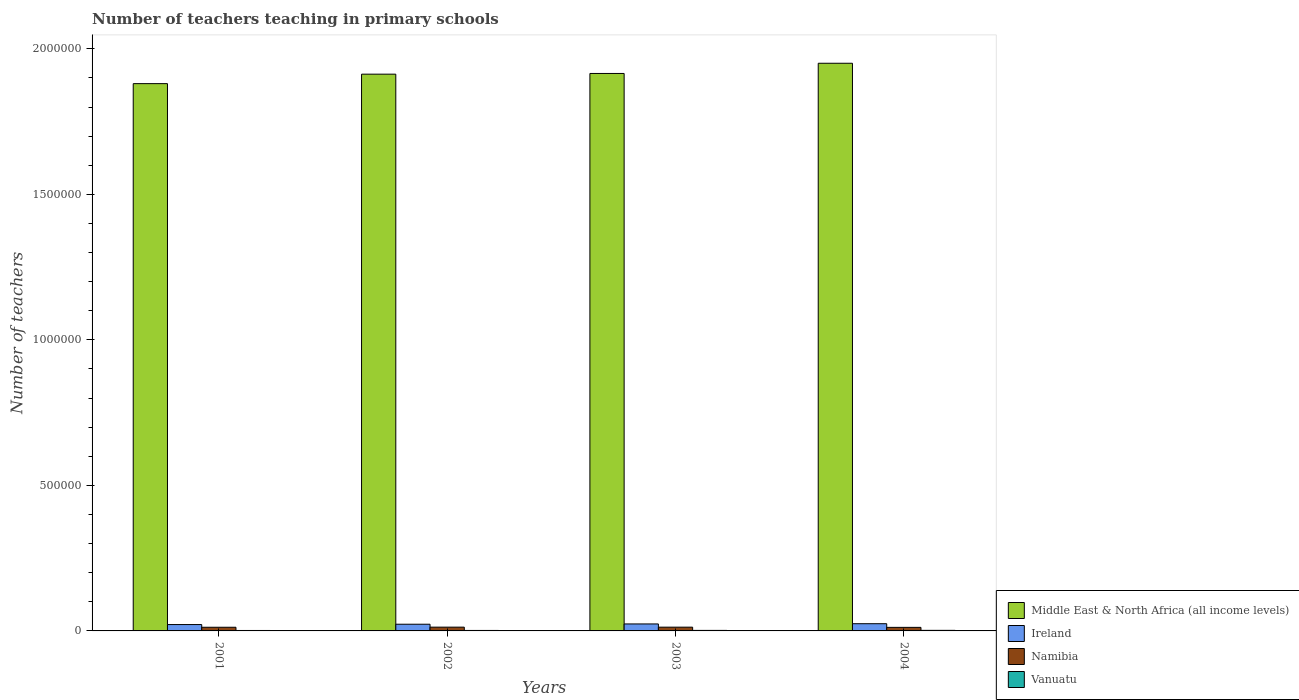How many different coloured bars are there?
Your answer should be compact. 4. Are the number of bars per tick equal to the number of legend labels?
Your response must be concise. Yes. Are the number of bars on each tick of the X-axis equal?
Provide a succinct answer. Yes. How many bars are there on the 4th tick from the left?
Offer a terse response. 4. How many bars are there on the 3rd tick from the right?
Offer a very short reply. 4. In how many cases, is the number of bars for a given year not equal to the number of legend labels?
Your answer should be compact. 0. What is the number of teachers teaching in primary schools in Vanuatu in 2003?
Give a very brief answer. 1814. Across all years, what is the maximum number of teachers teaching in primary schools in Namibia?
Offer a terse response. 1.30e+04. Across all years, what is the minimum number of teachers teaching in primary schools in Namibia?
Offer a very short reply. 1.22e+04. In which year was the number of teachers teaching in primary schools in Vanuatu maximum?
Offer a very short reply. 2004. What is the total number of teachers teaching in primary schools in Ireland in the graph?
Offer a very short reply. 9.36e+04. What is the difference between the number of teachers teaching in primary schools in Vanuatu in 2002 and that in 2003?
Keep it short and to the point. -200. What is the difference between the number of teachers teaching in primary schools in Middle East & North Africa (all income levels) in 2001 and the number of teachers teaching in primary schools in Vanuatu in 2002?
Provide a succinct answer. 1.88e+06. What is the average number of teachers teaching in primary schools in Ireland per year?
Your answer should be compact. 2.34e+04. In the year 2004, what is the difference between the number of teachers teaching in primary schools in Namibia and number of teachers teaching in primary schools in Middle East & North Africa (all income levels)?
Provide a short and direct response. -1.94e+06. In how many years, is the number of teachers teaching in primary schools in Middle East & North Africa (all income levels) greater than 200000?
Your answer should be very brief. 4. What is the ratio of the number of teachers teaching in primary schools in Ireland in 2001 to that in 2002?
Offer a very short reply. 0.95. Is the number of teachers teaching in primary schools in Ireland in 2001 less than that in 2002?
Your answer should be compact. Yes. Is the difference between the number of teachers teaching in primary schools in Namibia in 2001 and 2004 greater than the difference between the number of teachers teaching in primary schools in Middle East & North Africa (all income levels) in 2001 and 2004?
Offer a terse response. Yes. What is the difference between the highest and the second highest number of teachers teaching in primary schools in Ireland?
Your answer should be very brief. 820. What is the difference between the highest and the lowest number of teachers teaching in primary schools in Vanuatu?
Your answer should be compact. 410. What does the 2nd bar from the left in 2002 represents?
Your answer should be compact. Ireland. What does the 3rd bar from the right in 2002 represents?
Ensure brevity in your answer.  Ireland. Is it the case that in every year, the sum of the number of teachers teaching in primary schools in Ireland and number of teachers teaching in primary schools in Middle East & North Africa (all income levels) is greater than the number of teachers teaching in primary schools in Namibia?
Your response must be concise. Yes. How many bars are there?
Your answer should be very brief. 16. How many years are there in the graph?
Ensure brevity in your answer.  4. Where does the legend appear in the graph?
Offer a very short reply. Bottom right. How many legend labels are there?
Keep it short and to the point. 4. How are the legend labels stacked?
Offer a very short reply. Vertical. What is the title of the graph?
Provide a short and direct response. Number of teachers teaching in primary schools. What is the label or title of the X-axis?
Make the answer very short. Years. What is the label or title of the Y-axis?
Make the answer very short. Number of teachers. What is the Number of teachers in Middle East & North Africa (all income levels) in 2001?
Ensure brevity in your answer.  1.88e+06. What is the Number of teachers in Ireland in 2001?
Offer a very short reply. 2.19e+04. What is the Number of teachers of Namibia in 2001?
Make the answer very short. 1.26e+04. What is the Number of teachers in Vanuatu in 2001?
Give a very brief answer. 1537. What is the Number of teachers of Middle East & North Africa (all income levels) in 2002?
Keep it short and to the point. 1.91e+06. What is the Number of teachers of Ireland in 2002?
Provide a short and direct response. 2.30e+04. What is the Number of teachers in Namibia in 2002?
Make the answer very short. 1.30e+04. What is the Number of teachers of Vanuatu in 2002?
Provide a short and direct response. 1614. What is the Number of teachers in Middle East & North Africa (all income levels) in 2003?
Keep it short and to the point. 1.92e+06. What is the Number of teachers of Ireland in 2003?
Offer a terse response. 2.40e+04. What is the Number of teachers in Namibia in 2003?
Your answer should be very brief. 1.29e+04. What is the Number of teachers in Vanuatu in 2003?
Ensure brevity in your answer.  1814. What is the Number of teachers of Middle East & North Africa (all income levels) in 2004?
Ensure brevity in your answer.  1.95e+06. What is the Number of teachers in Ireland in 2004?
Give a very brief answer. 2.48e+04. What is the Number of teachers of Namibia in 2004?
Your response must be concise. 1.22e+04. What is the Number of teachers in Vanuatu in 2004?
Offer a terse response. 1947. Across all years, what is the maximum Number of teachers in Middle East & North Africa (all income levels)?
Keep it short and to the point. 1.95e+06. Across all years, what is the maximum Number of teachers of Ireland?
Your answer should be very brief. 2.48e+04. Across all years, what is the maximum Number of teachers in Namibia?
Keep it short and to the point. 1.30e+04. Across all years, what is the maximum Number of teachers in Vanuatu?
Your response must be concise. 1947. Across all years, what is the minimum Number of teachers of Middle East & North Africa (all income levels)?
Provide a succinct answer. 1.88e+06. Across all years, what is the minimum Number of teachers in Ireland?
Your answer should be compact. 2.19e+04. Across all years, what is the minimum Number of teachers in Namibia?
Keep it short and to the point. 1.22e+04. Across all years, what is the minimum Number of teachers of Vanuatu?
Your answer should be very brief. 1537. What is the total Number of teachers of Middle East & North Africa (all income levels) in the graph?
Your answer should be very brief. 7.66e+06. What is the total Number of teachers of Ireland in the graph?
Ensure brevity in your answer.  9.36e+04. What is the total Number of teachers in Namibia in the graph?
Provide a succinct answer. 5.07e+04. What is the total Number of teachers of Vanuatu in the graph?
Offer a terse response. 6912. What is the difference between the Number of teachers in Middle East & North Africa (all income levels) in 2001 and that in 2002?
Provide a succinct answer. -3.25e+04. What is the difference between the Number of teachers of Ireland in 2001 and that in 2002?
Your answer should be very brief. -1114. What is the difference between the Number of teachers in Namibia in 2001 and that in 2002?
Give a very brief answer. -391. What is the difference between the Number of teachers in Vanuatu in 2001 and that in 2002?
Give a very brief answer. -77. What is the difference between the Number of teachers in Middle East & North Africa (all income levels) in 2001 and that in 2003?
Make the answer very short. -3.50e+04. What is the difference between the Number of teachers in Ireland in 2001 and that in 2003?
Your answer should be compact. -2107. What is the difference between the Number of teachers in Namibia in 2001 and that in 2003?
Offer a very short reply. -347. What is the difference between the Number of teachers in Vanuatu in 2001 and that in 2003?
Ensure brevity in your answer.  -277. What is the difference between the Number of teachers in Middle East & North Africa (all income levels) in 2001 and that in 2004?
Your answer should be very brief. -7.00e+04. What is the difference between the Number of teachers of Ireland in 2001 and that in 2004?
Ensure brevity in your answer.  -2927. What is the difference between the Number of teachers of Namibia in 2001 and that in 2004?
Keep it short and to the point. 388. What is the difference between the Number of teachers of Vanuatu in 2001 and that in 2004?
Provide a succinct answer. -410. What is the difference between the Number of teachers in Middle East & North Africa (all income levels) in 2002 and that in 2003?
Keep it short and to the point. -2445.88. What is the difference between the Number of teachers of Ireland in 2002 and that in 2003?
Your answer should be very brief. -993. What is the difference between the Number of teachers in Namibia in 2002 and that in 2003?
Your answer should be compact. 44. What is the difference between the Number of teachers of Vanuatu in 2002 and that in 2003?
Make the answer very short. -200. What is the difference between the Number of teachers in Middle East & North Africa (all income levels) in 2002 and that in 2004?
Keep it short and to the point. -3.75e+04. What is the difference between the Number of teachers of Ireland in 2002 and that in 2004?
Keep it short and to the point. -1813. What is the difference between the Number of teachers in Namibia in 2002 and that in 2004?
Provide a succinct answer. 779. What is the difference between the Number of teachers in Vanuatu in 2002 and that in 2004?
Your answer should be very brief. -333. What is the difference between the Number of teachers in Middle East & North Africa (all income levels) in 2003 and that in 2004?
Provide a short and direct response. -3.50e+04. What is the difference between the Number of teachers of Ireland in 2003 and that in 2004?
Your response must be concise. -820. What is the difference between the Number of teachers of Namibia in 2003 and that in 2004?
Your response must be concise. 735. What is the difference between the Number of teachers of Vanuatu in 2003 and that in 2004?
Your answer should be very brief. -133. What is the difference between the Number of teachers of Middle East & North Africa (all income levels) in 2001 and the Number of teachers of Ireland in 2002?
Your answer should be very brief. 1.86e+06. What is the difference between the Number of teachers of Middle East & North Africa (all income levels) in 2001 and the Number of teachers of Namibia in 2002?
Your response must be concise. 1.87e+06. What is the difference between the Number of teachers of Middle East & North Africa (all income levels) in 2001 and the Number of teachers of Vanuatu in 2002?
Provide a short and direct response. 1.88e+06. What is the difference between the Number of teachers in Ireland in 2001 and the Number of teachers in Namibia in 2002?
Ensure brevity in your answer.  8895. What is the difference between the Number of teachers in Ireland in 2001 and the Number of teachers in Vanuatu in 2002?
Ensure brevity in your answer.  2.03e+04. What is the difference between the Number of teachers of Namibia in 2001 and the Number of teachers of Vanuatu in 2002?
Give a very brief answer. 1.10e+04. What is the difference between the Number of teachers of Middle East & North Africa (all income levels) in 2001 and the Number of teachers of Ireland in 2003?
Your answer should be very brief. 1.86e+06. What is the difference between the Number of teachers in Middle East & North Africa (all income levels) in 2001 and the Number of teachers in Namibia in 2003?
Provide a succinct answer. 1.87e+06. What is the difference between the Number of teachers of Middle East & North Africa (all income levels) in 2001 and the Number of teachers of Vanuatu in 2003?
Ensure brevity in your answer.  1.88e+06. What is the difference between the Number of teachers in Ireland in 2001 and the Number of teachers in Namibia in 2003?
Offer a very short reply. 8939. What is the difference between the Number of teachers in Ireland in 2001 and the Number of teachers in Vanuatu in 2003?
Your response must be concise. 2.01e+04. What is the difference between the Number of teachers of Namibia in 2001 and the Number of teachers of Vanuatu in 2003?
Your response must be concise. 1.08e+04. What is the difference between the Number of teachers of Middle East & North Africa (all income levels) in 2001 and the Number of teachers of Ireland in 2004?
Your answer should be compact. 1.86e+06. What is the difference between the Number of teachers in Middle East & North Africa (all income levels) in 2001 and the Number of teachers in Namibia in 2004?
Make the answer very short. 1.87e+06. What is the difference between the Number of teachers of Middle East & North Africa (all income levels) in 2001 and the Number of teachers of Vanuatu in 2004?
Your answer should be compact. 1.88e+06. What is the difference between the Number of teachers in Ireland in 2001 and the Number of teachers in Namibia in 2004?
Ensure brevity in your answer.  9674. What is the difference between the Number of teachers of Ireland in 2001 and the Number of teachers of Vanuatu in 2004?
Ensure brevity in your answer.  1.99e+04. What is the difference between the Number of teachers in Namibia in 2001 and the Number of teachers in Vanuatu in 2004?
Offer a terse response. 1.06e+04. What is the difference between the Number of teachers of Middle East & North Africa (all income levels) in 2002 and the Number of teachers of Ireland in 2003?
Offer a terse response. 1.89e+06. What is the difference between the Number of teachers of Middle East & North Africa (all income levels) in 2002 and the Number of teachers of Namibia in 2003?
Provide a short and direct response. 1.90e+06. What is the difference between the Number of teachers of Middle East & North Africa (all income levels) in 2002 and the Number of teachers of Vanuatu in 2003?
Offer a very short reply. 1.91e+06. What is the difference between the Number of teachers of Ireland in 2002 and the Number of teachers of Namibia in 2003?
Make the answer very short. 1.01e+04. What is the difference between the Number of teachers in Ireland in 2002 and the Number of teachers in Vanuatu in 2003?
Your response must be concise. 2.12e+04. What is the difference between the Number of teachers in Namibia in 2002 and the Number of teachers in Vanuatu in 2003?
Your answer should be very brief. 1.12e+04. What is the difference between the Number of teachers of Middle East & North Africa (all income levels) in 2002 and the Number of teachers of Ireland in 2004?
Your response must be concise. 1.89e+06. What is the difference between the Number of teachers in Middle East & North Africa (all income levels) in 2002 and the Number of teachers in Namibia in 2004?
Give a very brief answer. 1.90e+06. What is the difference between the Number of teachers of Middle East & North Africa (all income levels) in 2002 and the Number of teachers of Vanuatu in 2004?
Your answer should be very brief. 1.91e+06. What is the difference between the Number of teachers of Ireland in 2002 and the Number of teachers of Namibia in 2004?
Offer a terse response. 1.08e+04. What is the difference between the Number of teachers of Ireland in 2002 and the Number of teachers of Vanuatu in 2004?
Offer a very short reply. 2.10e+04. What is the difference between the Number of teachers of Namibia in 2002 and the Number of teachers of Vanuatu in 2004?
Provide a short and direct response. 1.10e+04. What is the difference between the Number of teachers of Middle East & North Africa (all income levels) in 2003 and the Number of teachers of Ireland in 2004?
Make the answer very short. 1.89e+06. What is the difference between the Number of teachers in Middle East & North Africa (all income levels) in 2003 and the Number of teachers in Namibia in 2004?
Make the answer very short. 1.90e+06. What is the difference between the Number of teachers of Middle East & North Africa (all income levels) in 2003 and the Number of teachers of Vanuatu in 2004?
Your answer should be very brief. 1.91e+06. What is the difference between the Number of teachers of Ireland in 2003 and the Number of teachers of Namibia in 2004?
Your answer should be compact. 1.18e+04. What is the difference between the Number of teachers in Ireland in 2003 and the Number of teachers in Vanuatu in 2004?
Ensure brevity in your answer.  2.20e+04. What is the difference between the Number of teachers in Namibia in 2003 and the Number of teachers in Vanuatu in 2004?
Keep it short and to the point. 1.10e+04. What is the average Number of teachers of Middle East & North Africa (all income levels) per year?
Provide a succinct answer. 1.91e+06. What is the average Number of teachers of Ireland per year?
Offer a terse response. 2.34e+04. What is the average Number of teachers of Namibia per year?
Ensure brevity in your answer.  1.27e+04. What is the average Number of teachers in Vanuatu per year?
Keep it short and to the point. 1728. In the year 2001, what is the difference between the Number of teachers of Middle East & North Africa (all income levels) and Number of teachers of Ireland?
Offer a terse response. 1.86e+06. In the year 2001, what is the difference between the Number of teachers of Middle East & North Africa (all income levels) and Number of teachers of Namibia?
Give a very brief answer. 1.87e+06. In the year 2001, what is the difference between the Number of teachers of Middle East & North Africa (all income levels) and Number of teachers of Vanuatu?
Make the answer very short. 1.88e+06. In the year 2001, what is the difference between the Number of teachers of Ireland and Number of teachers of Namibia?
Provide a succinct answer. 9286. In the year 2001, what is the difference between the Number of teachers in Ireland and Number of teachers in Vanuatu?
Your answer should be compact. 2.03e+04. In the year 2001, what is the difference between the Number of teachers of Namibia and Number of teachers of Vanuatu?
Ensure brevity in your answer.  1.10e+04. In the year 2002, what is the difference between the Number of teachers of Middle East & North Africa (all income levels) and Number of teachers of Ireland?
Your answer should be compact. 1.89e+06. In the year 2002, what is the difference between the Number of teachers in Middle East & North Africa (all income levels) and Number of teachers in Namibia?
Your answer should be compact. 1.90e+06. In the year 2002, what is the difference between the Number of teachers of Middle East & North Africa (all income levels) and Number of teachers of Vanuatu?
Keep it short and to the point. 1.91e+06. In the year 2002, what is the difference between the Number of teachers of Ireland and Number of teachers of Namibia?
Ensure brevity in your answer.  1.00e+04. In the year 2002, what is the difference between the Number of teachers in Ireland and Number of teachers in Vanuatu?
Your response must be concise. 2.14e+04. In the year 2002, what is the difference between the Number of teachers of Namibia and Number of teachers of Vanuatu?
Your response must be concise. 1.14e+04. In the year 2003, what is the difference between the Number of teachers in Middle East & North Africa (all income levels) and Number of teachers in Ireland?
Your answer should be compact. 1.89e+06. In the year 2003, what is the difference between the Number of teachers of Middle East & North Africa (all income levels) and Number of teachers of Namibia?
Offer a terse response. 1.90e+06. In the year 2003, what is the difference between the Number of teachers of Middle East & North Africa (all income levels) and Number of teachers of Vanuatu?
Provide a succinct answer. 1.91e+06. In the year 2003, what is the difference between the Number of teachers in Ireland and Number of teachers in Namibia?
Give a very brief answer. 1.10e+04. In the year 2003, what is the difference between the Number of teachers in Ireland and Number of teachers in Vanuatu?
Provide a succinct answer. 2.22e+04. In the year 2003, what is the difference between the Number of teachers in Namibia and Number of teachers in Vanuatu?
Your response must be concise. 1.11e+04. In the year 2004, what is the difference between the Number of teachers of Middle East & North Africa (all income levels) and Number of teachers of Ireland?
Offer a very short reply. 1.93e+06. In the year 2004, what is the difference between the Number of teachers in Middle East & North Africa (all income levels) and Number of teachers in Namibia?
Your response must be concise. 1.94e+06. In the year 2004, what is the difference between the Number of teachers in Middle East & North Africa (all income levels) and Number of teachers in Vanuatu?
Make the answer very short. 1.95e+06. In the year 2004, what is the difference between the Number of teachers in Ireland and Number of teachers in Namibia?
Provide a succinct answer. 1.26e+04. In the year 2004, what is the difference between the Number of teachers in Ireland and Number of teachers in Vanuatu?
Your answer should be compact. 2.28e+04. In the year 2004, what is the difference between the Number of teachers of Namibia and Number of teachers of Vanuatu?
Give a very brief answer. 1.02e+04. What is the ratio of the Number of teachers of Middle East & North Africa (all income levels) in 2001 to that in 2002?
Your response must be concise. 0.98. What is the ratio of the Number of teachers of Ireland in 2001 to that in 2002?
Your answer should be very brief. 0.95. What is the ratio of the Number of teachers in Namibia in 2001 to that in 2002?
Ensure brevity in your answer.  0.97. What is the ratio of the Number of teachers in Vanuatu in 2001 to that in 2002?
Offer a terse response. 0.95. What is the ratio of the Number of teachers in Middle East & North Africa (all income levels) in 2001 to that in 2003?
Your answer should be compact. 0.98. What is the ratio of the Number of teachers in Ireland in 2001 to that in 2003?
Offer a very short reply. 0.91. What is the ratio of the Number of teachers in Namibia in 2001 to that in 2003?
Keep it short and to the point. 0.97. What is the ratio of the Number of teachers in Vanuatu in 2001 to that in 2003?
Offer a very short reply. 0.85. What is the ratio of the Number of teachers of Middle East & North Africa (all income levels) in 2001 to that in 2004?
Your response must be concise. 0.96. What is the ratio of the Number of teachers of Ireland in 2001 to that in 2004?
Offer a terse response. 0.88. What is the ratio of the Number of teachers of Namibia in 2001 to that in 2004?
Provide a succinct answer. 1.03. What is the ratio of the Number of teachers in Vanuatu in 2001 to that in 2004?
Offer a very short reply. 0.79. What is the ratio of the Number of teachers in Ireland in 2002 to that in 2003?
Provide a succinct answer. 0.96. What is the ratio of the Number of teachers of Namibia in 2002 to that in 2003?
Offer a terse response. 1. What is the ratio of the Number of teachers of Vanuatu in 2002 to that in 2003?
Your answer should be compact. 0.89. What is the ratio of the Number of teachers of Middle East & North Africa (all income levels) in 2002 to that in 2004?
Keep it short and to the point. 0.98. What is the ratio of the Number of teachers in Ireland in 2002 to that in 2004?
Give a very brief answer. 0.93. What is the ratio of the Number of teachers in Namibia in 2002 to that in 2004?
Offer a very short reply. 1.06. What is the ratio of the Number of teachers in Vanuatu in 2002 to that in 2004?
Provide a succinct answer. 0.83. What is the ratio of the Number of teachers of Ireland in 2003 to that in 2004?
Ensure brevity in your answer.  0.97. What is the ratio of the Number of teachers in Namibia in 2003 to that in 2004?
Keep it short and to the point. 1.06. What is the ratio of the Number of teachers of Vanuatu in 2003 to that in 2004?
Make the answer very short. 0.93. What is the difference between the highest and the second highest Number of teachers of Middle East & North Africa (all income levels)?
Provide a short and direct response. 3.50e+04. What is the difference between the highest and the second highest Number of teachers of Ireland?
Ensure brevity in your answer.  820. What is the difference between the highest and the second highest Number of teachers in Vanuatu?
Give a very brief answer. 133. What is the difference between the highest and the lowest Number of teachers of Middle East & North Africa (all income levels)?
Offer a very short reply. 7.00e+04. What is the difference between the highest and the lowest Number of teachers in Ireland?
Offer a very short reply. 2927. What is the difference between the highest and the lowest Number of teachers in Namibia?
Offer a very short reply. 779. What is the difference between the highest and the lowest Number of teachers in Vanuatu?
Ensure brevity in your answer.  410. 